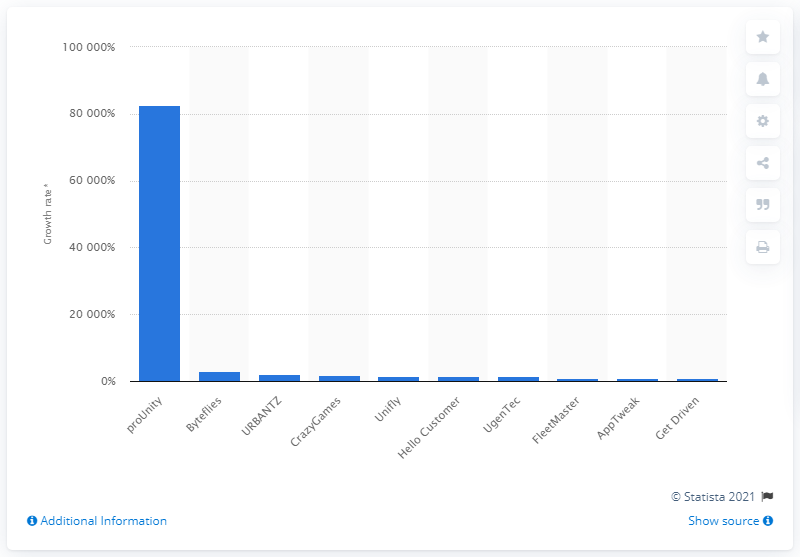Outline some significant characteristics in this image. In 2020, the number one technology company in Belgium was proUnity. 